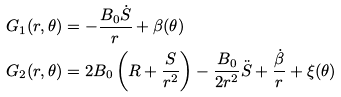Convert formula to latex. <formula><loc_0><loc_0><loc_500><loc_500>G _ { 1 } ( r , \theta ) & = - \frac { B _ { 0 } \dot { S } } { r } + \beta ( \theta ) \\ G _ { 2 } ( r , \theta ) & = 2 B _ { 0 } \left ( R + \frac { S } { r ^ { 2 } } \right ) - \frac { B _ { 0 } } { 2 r ^ { 2 } } \ddot { S } + \frac { \dot { \beta } } { r } + \xi ( \theta )</formula> 